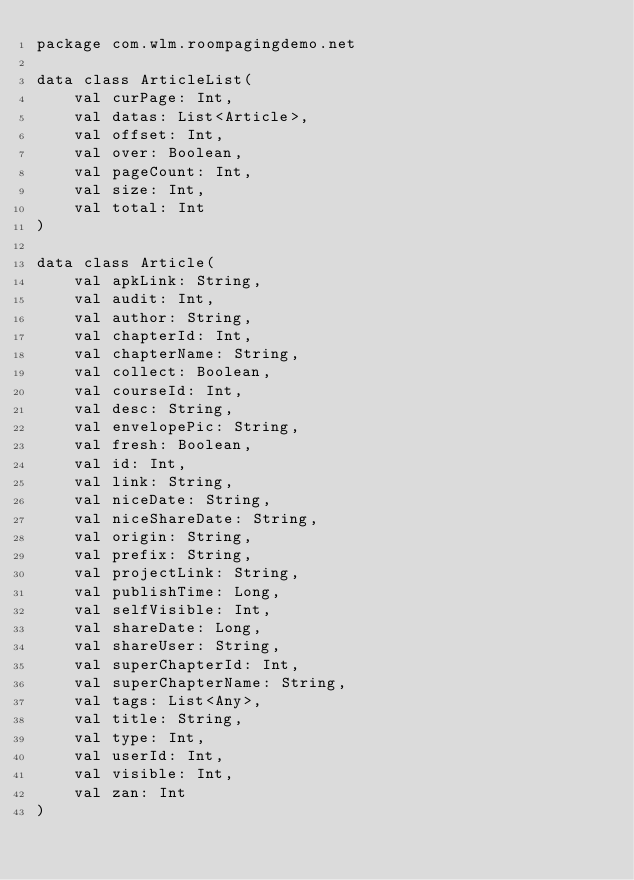Convert code to text. <code><loc_0><loc_0><loc_500><loc_500><_Kotlin_>package com.wlm.roompagingdemo.net

data class ArticleList(
    val curPage: Int,
    val datas: List<Article>,
    val offset: Int,
    val over: Boolean,
    val pageCount: Int,
    val size: Int,
    val total: Int
)

data class Article(
    val apkLink: String,
    val audit: Int,
    val author: String,
    val chapterId: Int,
    val chapterName: String,
    val collect: Boolean,
    val courseId: Int,
    val desc: String,
    val envelopePic: String,
    val fresh: Boolean,
    val id: Int,
    val link: String,
    val niceDate: String,
    val niceShareDate: String,
    val origin: String,
    val prefix: String,
    val projectLink: String,
    val publishTime: Long,
    val selfVisible: Int,
    val shareDate: Long,
    val shareUser: String,
    val superChapterId: Int,
    val superChapterName: String,
    val tags: List<Any>,
    val title: String,
    val type: Int,
    val userId: Int,
    val visible: Int,
    val zan: Int
)
</code> 